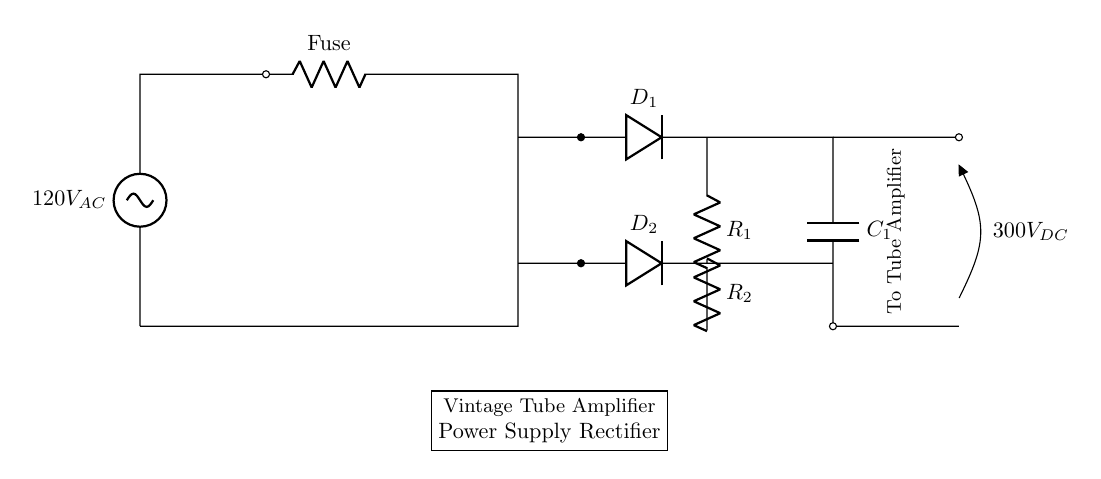What is the input voltage of this circuit? The input voltage is labeled as 120V AC, which is the voltage supplied to the circuit for operation.
Answer: 120V AC What type of diodes are used in this rectifier? The circuit diagram shows two diodes labeled as D1 and D2; therefore, the diodes used are likely silicon diodes, commonly used in rectifiers.
Answer: Silicon diodes What is the output voltage of this circuit? The output voltage is marked as 300V DC, which indicates the voltage delivered to the tube amplifier after rectification.
Answer: 300V DC What is the purpose of the transformer in this circuit? The transformer is used to step down or isolate the AC voltage before it is rectified, ensuring the voltage level is appropriate for tube amplifiers.
Answer: Voltage isolation How do the resistors R1 and R2 affect the circuit? Resistors R1 and R2 are likely used for load balancing, stabilizing output voltage, or limiting current within the circuit. Their values will influence the performance of the rectifier and connected components.
Answer: Load balancing Why are there capacitors in the circuit? The capacitor C1 is used for filtering in the rectification process, smoothing out the pulsating DC output from the diodes, which is crucial for the performance of the tube amplifier.
Answer: Smoothing DC output 